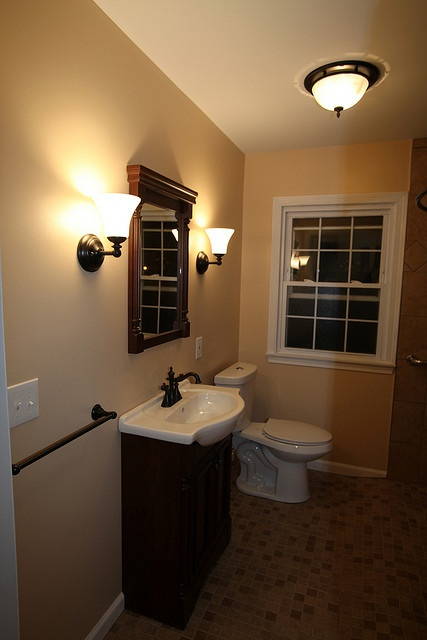Describe the objects in this image and their specific colors. I can see toilet in olive, black, gray, and maroon tones and sink in olive, tan, and gray tones in this image. 